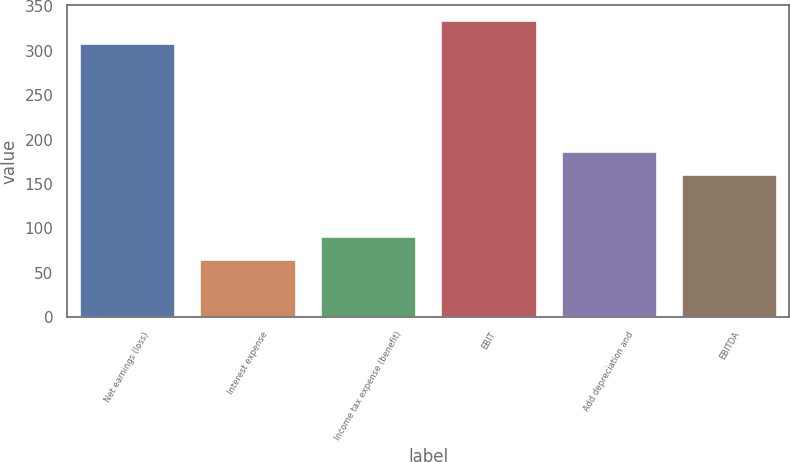Convert chart. <chart><loc_0><loc_0><loc_500><loc_500><bar_chart><fcel>Net earnings (loss)<fcel>Interest expense<fcel>Income tax expense (benefit)<fcel>EBIT<fcel>Add depreciation and<fcel>EBITDA<nl><fcel>309.1<fcel>65.9<fcel>91.91<fcel>335.11<fcel>187.01<fcel>161<nl></chart> 